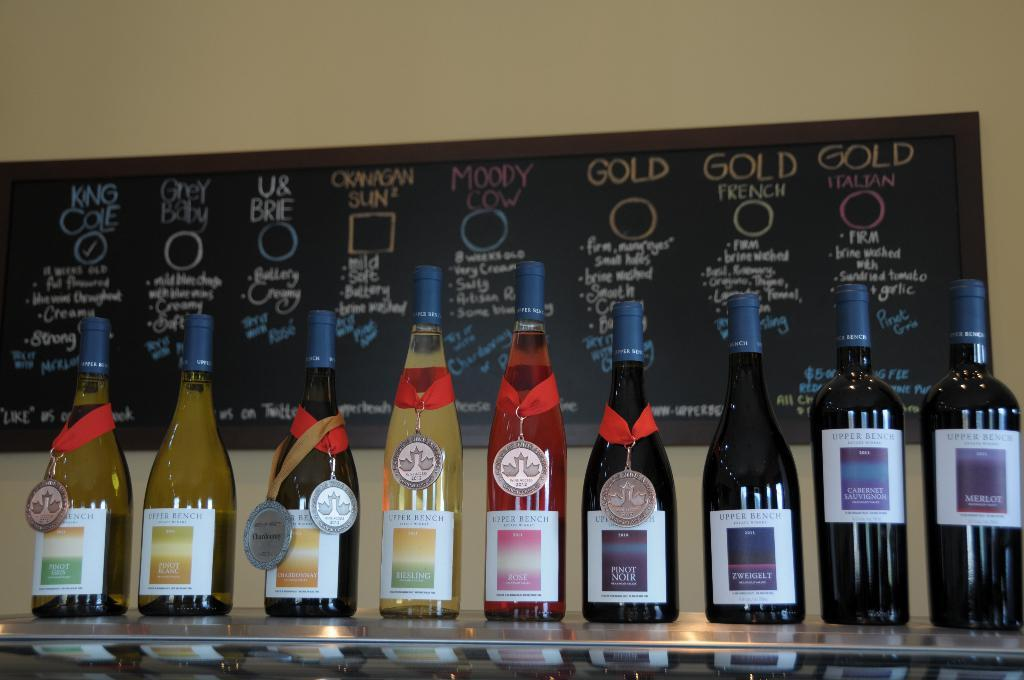<image>
Relay a brief, clear account of the picture shown. A wine bottle labeled King Cole won a medal. 